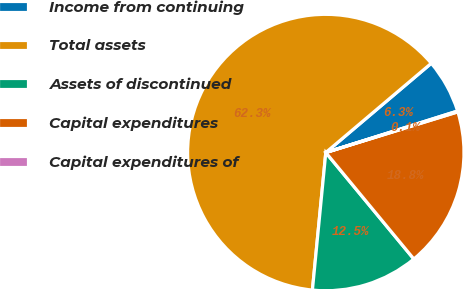Convert chart to OTSL. <chart><loc_0><loc_0><loc_500><loc_500><pie_chart><fcel>Income from continuing<fcel>Total assets<fcel>Assets of discontinued<fcel>Capital expenditures<fcel>Capital expenditures of<nl><fcel>6.32%<fcel>62.28%<fcel>12.54%<fcel>18.76%<fcel>0.1%<nl></chart> 